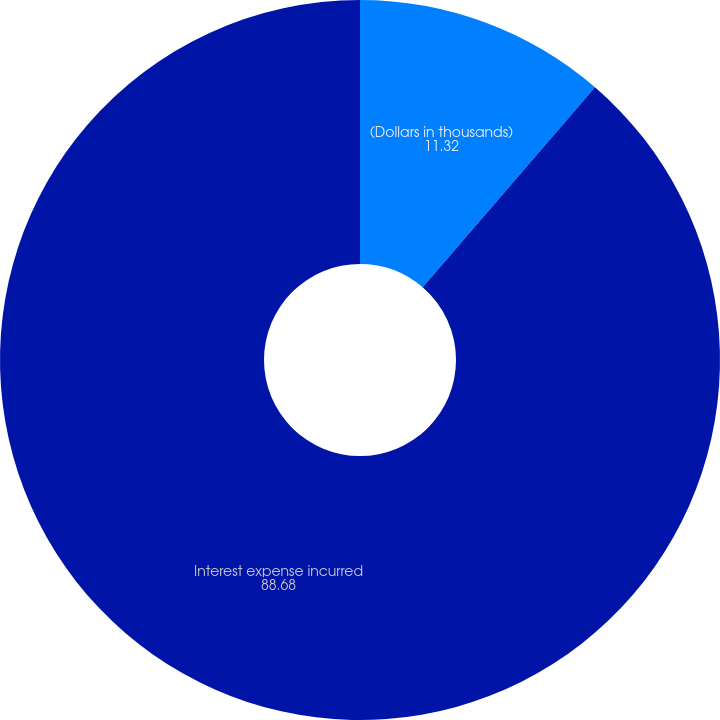Convert chart to OTSL. <chart><loc_0><loc_0><loc_500><loc_500><pie_chart><fcel>(Dollars in thousands)<fcel>Interest expense incurred<nl><fcel>11.32%<fcel>88.68%<nl></chart> 